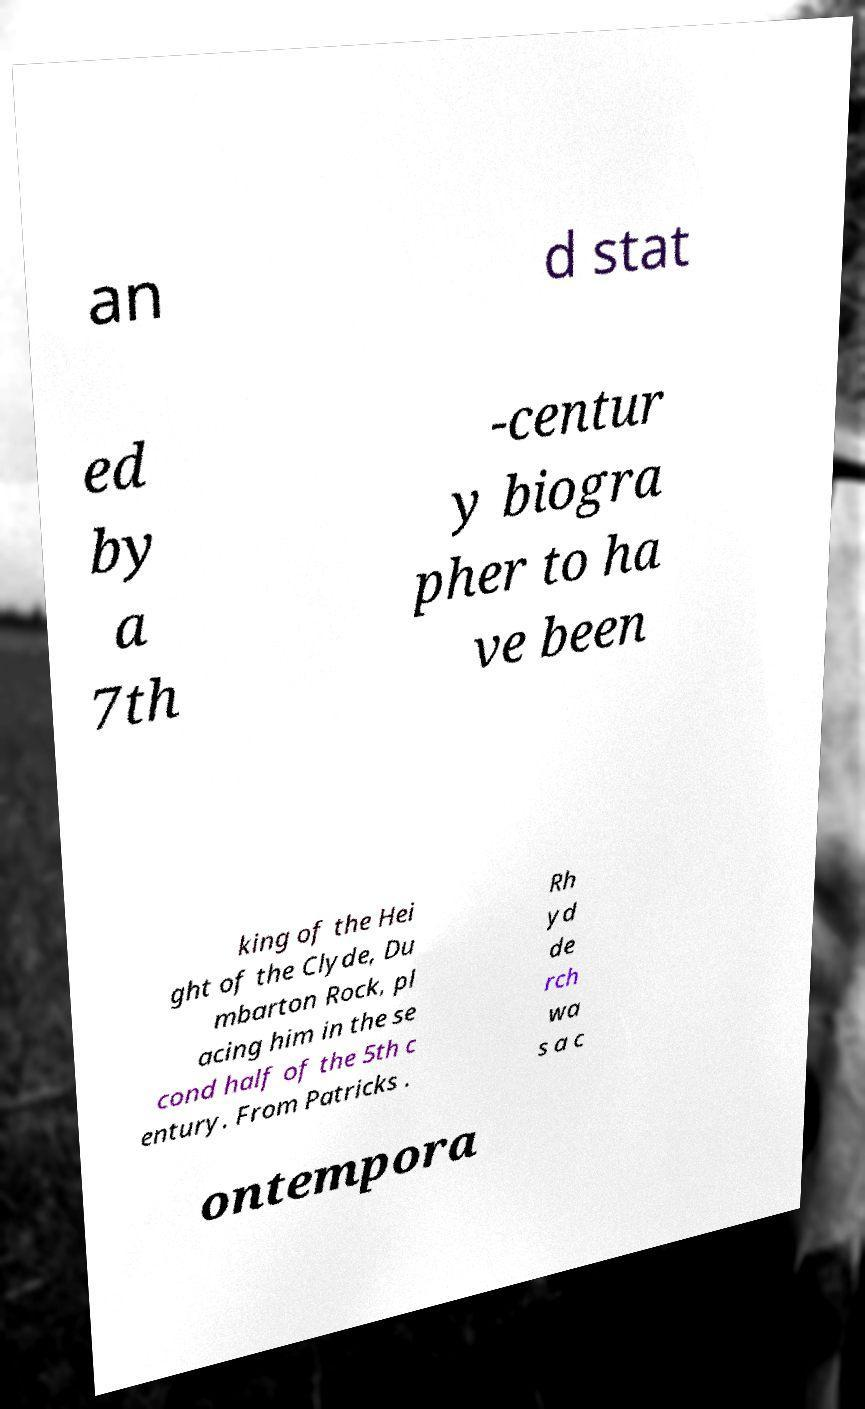Could you extract and type out the text from this image? an d stat ed by a 7th -centur y biogra pher to ha ve been king of the Hei ght of the Clyde, Du mbarton Rock, pl acing him in the se cond half of the 5th c entury. From Patricks . Rh yd de rch wa s a c ontempora 